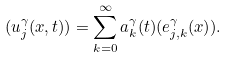Convert formula to latex. <formula><loc_0><loc_0><loc_500><loc_500>( u _ { j } ^ { \gamma } ( x , t ) ) = \sum _ { k = 0 } ^ { \infty } a _ { k } ^ { \gamma } ( t ) ( e _ { j , k } ^ { \gamma } ( x ) ) .</formula> 